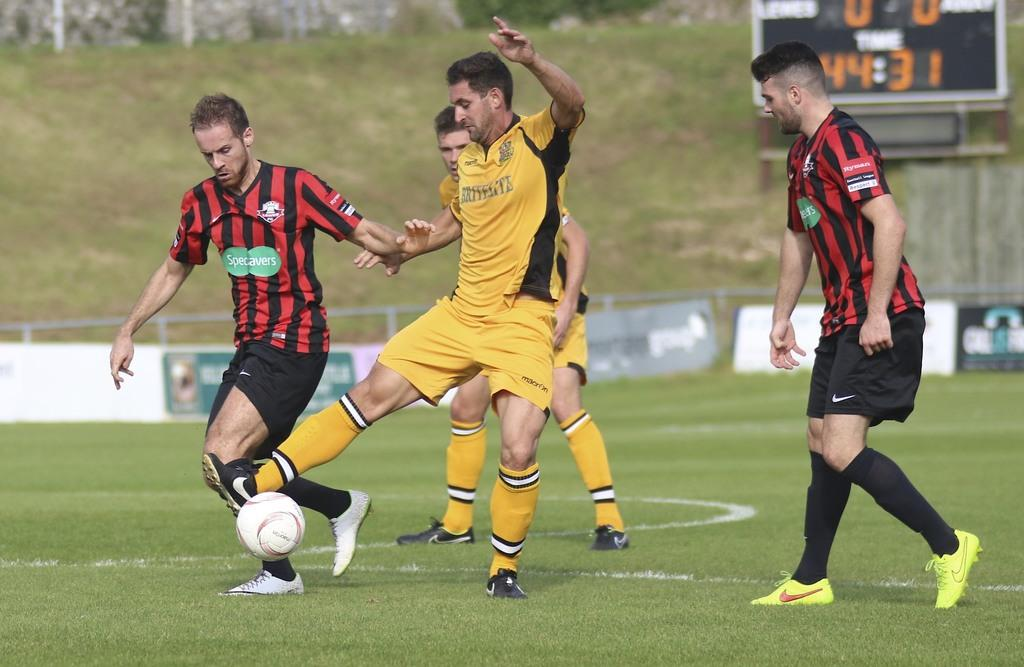What sport are the players in the image participating in? The players are playing football. What is the playing surface in the image? The football game is taking place on the ground. How many players are visible in the image? There are four players in the image, belonging to two different teams. What can be seen in the background of the image? There is grass and a scoreboard in the background of the image. What type of crime is being committed by the ladybug in the image? There is no ladybug present in the image, and therefore no crime can be committed by one. 